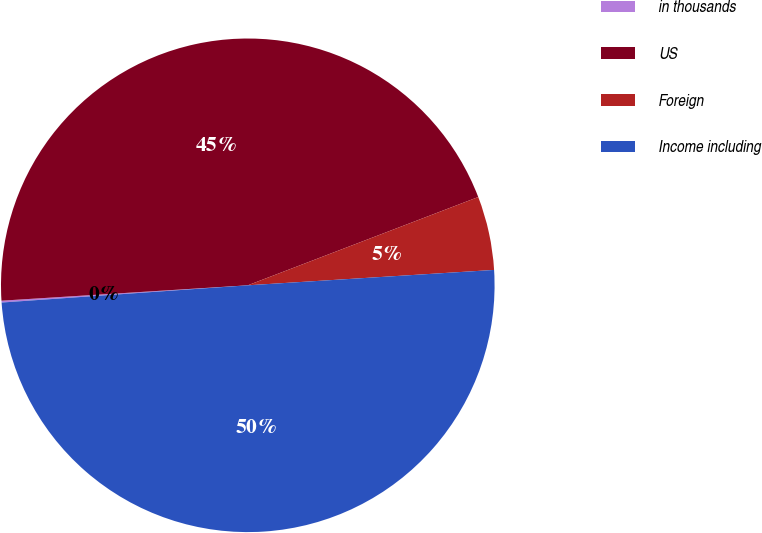<chart> <loc_0><loc_0><loc_500><loc_500><pie_chart><fcel>in thousands<fcel>US<fcel>Foreign<fcel>Income including<nl><fcel>0.12%<fcel>45.17%<fcel>4.83%<fcel>49.88%<nl></chart> 